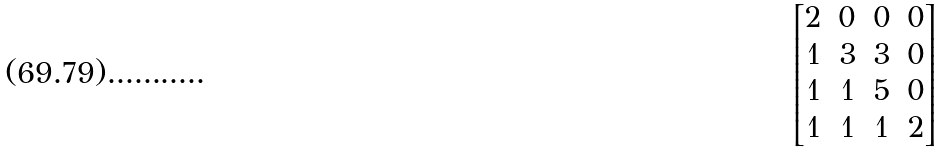Convert formula to latex. <formula><loc_0><loc_0><loc_500><loc_500>\begin{bmatrix} 2 & 0 & 0 & 0 \\ 1 & 3 & 3 & 0 \\ 1 & 1 & 5 & 0 \\ 1 & 1 & 1 & 2 \end{bmatrix}</formula> 